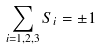<formula> <loc_0><loc_0><loc_500><loc_500>\sum _ { i = 1 , 2 , 3 } S _ { i } = \pm 1</formula> 